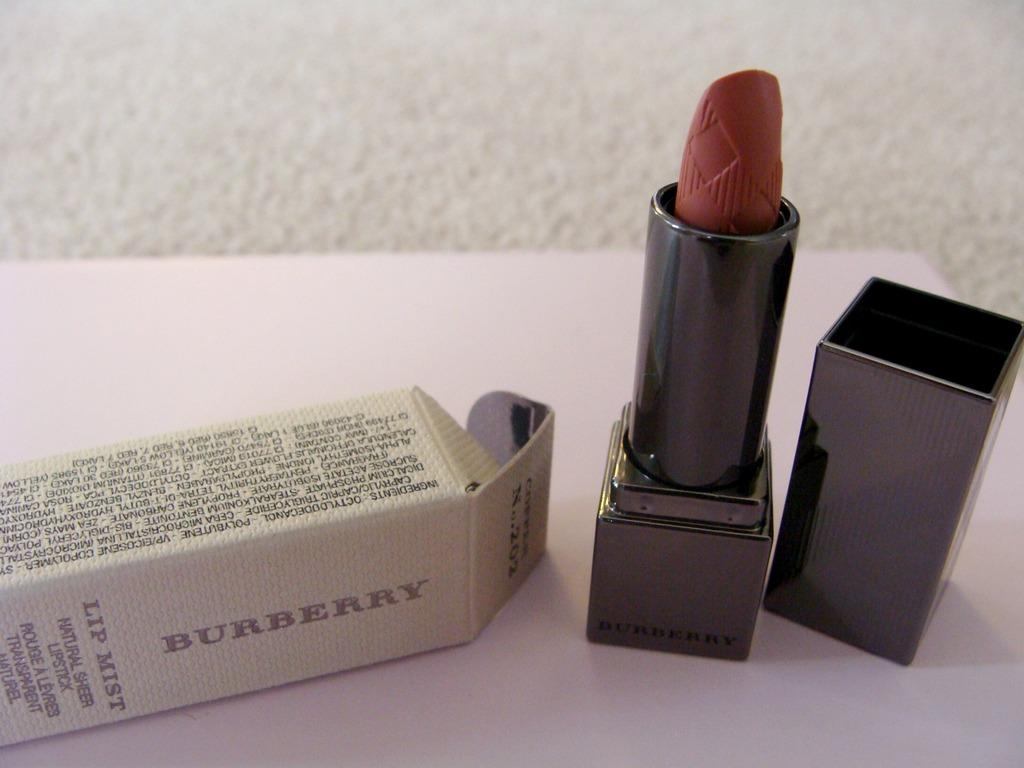<image>
Present a compact description of the photo's key features. A tube of lipstick with the brand on the box showing Burberry. 